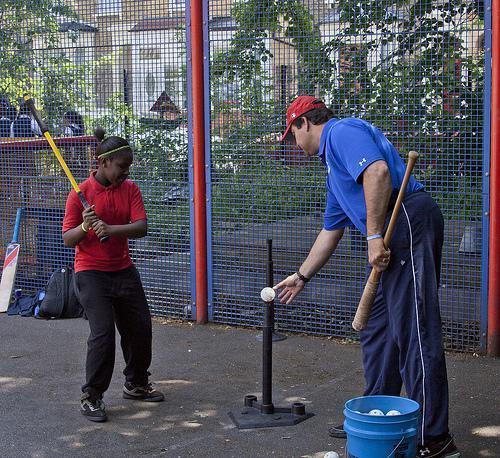How many people appear in this picture?
Give a very brief answer. 2. 